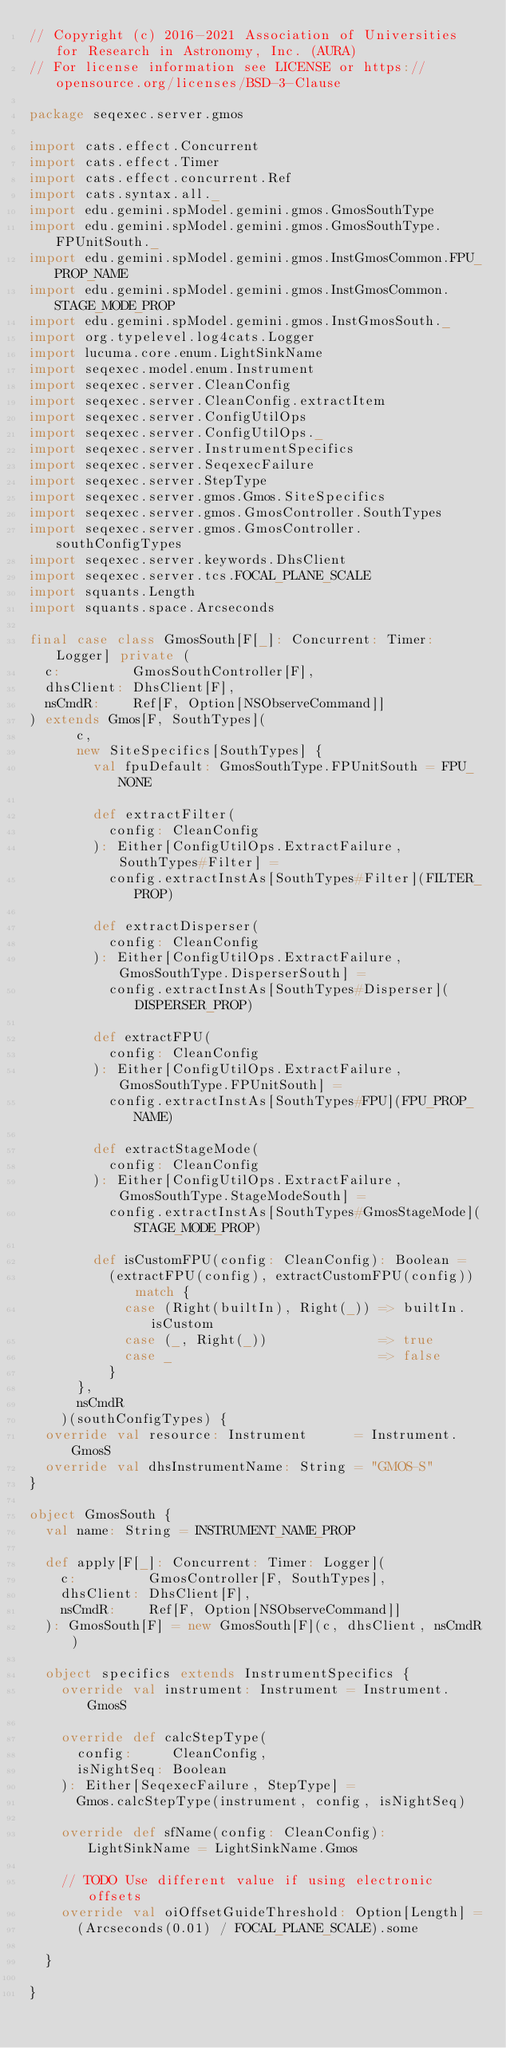Convert code to text. <code><loc_0><loc_0><loc_500><loc_500><_Scala_>// Copyright (c) 2016-2021 Association of Universities for Research in Astronomy, Inc. (AURA)
// For license information see LICENSE or https://opensource.org/licenses/BSD-3-Clause

package seqexec.server.gmos

import cats.effect.Concurrent
import cats.effect.Timer
import cats.effect.concurrent.Ref
import cats.syntax.all._
import edu.gemini.spModel.gemini.gmos.GmosSouthType
import edu.gemini.spModel.gemini.gmos.GmosSouthType.FPUnitSouth._
import edu.gemini.spModel.gemini.gmos.InstGmosCommon.FPU_PROP_NAME
import edu.gemini.spModel.gemini.gmos.InstGmosCommon.STAGE_MODE_PROP
import edu.gemini.spModel.gemini.gmos.InstGmosSouth._
import org.typelevel.log4cats.Logger
import lucuma.core.enum.LightSinkName
import seqexec.model.enum.Instrument
import seqexec.server.CleanConfig
import seqexec.server.CleanConfig.extractItem
import seqexec.server.ConfigUtilOps
import seqexec.server.ConfigUtilOps._
import seqexec.server.InstrumentSpecifics
import seqexec.server.SeqexecFailure
import seqexec.server.StepType
import seqexec.server.gmos.Gmos.SiteSpecifics
import seqexec.server.gmos.GmosController.SouthTypes
import seqexec.server.gmos.GmosController.southConfigTypes
import seqexec.server.keywords.DhsClient
import seqexec.server.tcs.FOCAL_PLANE_SCALE
import squants.Length
import squants.space.Arcseconds

final case class GmosSouth[F[_]: Concurrent: Timer: Logger] private (
  c:         GmosSouthController[F],
  dhsClient: DhsClient[F],
  nsCmdR:    Ref[F, Option[NSObserveCommand]]
) extends Gmos[F, SouthTypes](
      c,
      new SiteSpecifics[SouthTypes] {
        val fpuDefault: GmosSouthType.FPUnitSouth = FPU_NONE

        def extractFilter(
          config: CleanConfig
        ): Either[ConfigUtilOps.ExtractFailure, SouthTypes#Filter] =
          config.extractInstAs[SouthTypes#Filter](FILTER_PROP)

        def extractDisperser(
          config: CleanConfig
        ): Either[ConfigUtilOps.ExtractFailure, GmosSouthType.DisperserSouth] =
          config.extractInstAs[SouthTypes#Disperser](DISPERSER_PROP)

        def extractFPU(
          config: CleanConfig
        ): Either[ConfigUtilOps.ExtractFailure, GmosSouthType.FPUnitSouth] =
          config.extractInstAs[SouthTypes#FPU](FPU_PROP_NAME)

        def extractStageMode(
          config: CleanConfig
        ): Either[ConfigUtilOps.ExtractFailure, GmosSouthType.StageModeSouth] =
          config.extractInstAs[SouthTypes#GmosStageMode](STAGE_MODE_PROP)

        def isCustomFPU(config: CleanConfig): Boolean =
          (extractFPU(config), extractCustomFPU(config)) match {
            case (Right(builtIn), Right(_)) => builtIn.isCustom
            case (_, Right(_))              => true
            case _                          => false
          }
      },
      nsCmdR
    )(southConfigTypes) {
  override val resource: Instrument      = Instrument.GmosS
  override val dhsInstrumentName: String = "GMOS-S"
}

object GmosSouth {
  val name: String = INSTRUMENT_NAME_PROP

  def apply[F[_]: Concurrent: Timer: Logger](
    c:         GmosController[F, SouthTypes],
    dhsClient: DhsClient[F],
    nsCmdR:    Ref[F, Option[NSObserveCommand]]
  ): GmosSouth[F] = new GmosSouth[F](c, dhsClient, nsCmdR)

  object specifics extends InstrumentSpecifics {
    override val instrument: Instrument = Instrument.GmosS

    override def calcStepType(
      config:     CleanConfig,
      isNightSeq: Boolean
    ): Either[SeqexecFailure, StepType] =
      Gmos.calcStepType(instrument, config, isNightSeq)

    override def sfName(config: CleanConfig): LightSinkName = LightSinkName.Gmos

    // TODO Use different value if using electronic offsets
    override val oiOffsetGuideThreshold: Option[Length] =
      (Arcseconds(0.01) / FOCAL_PLANE_SCALE).some

  }

}
</code> 